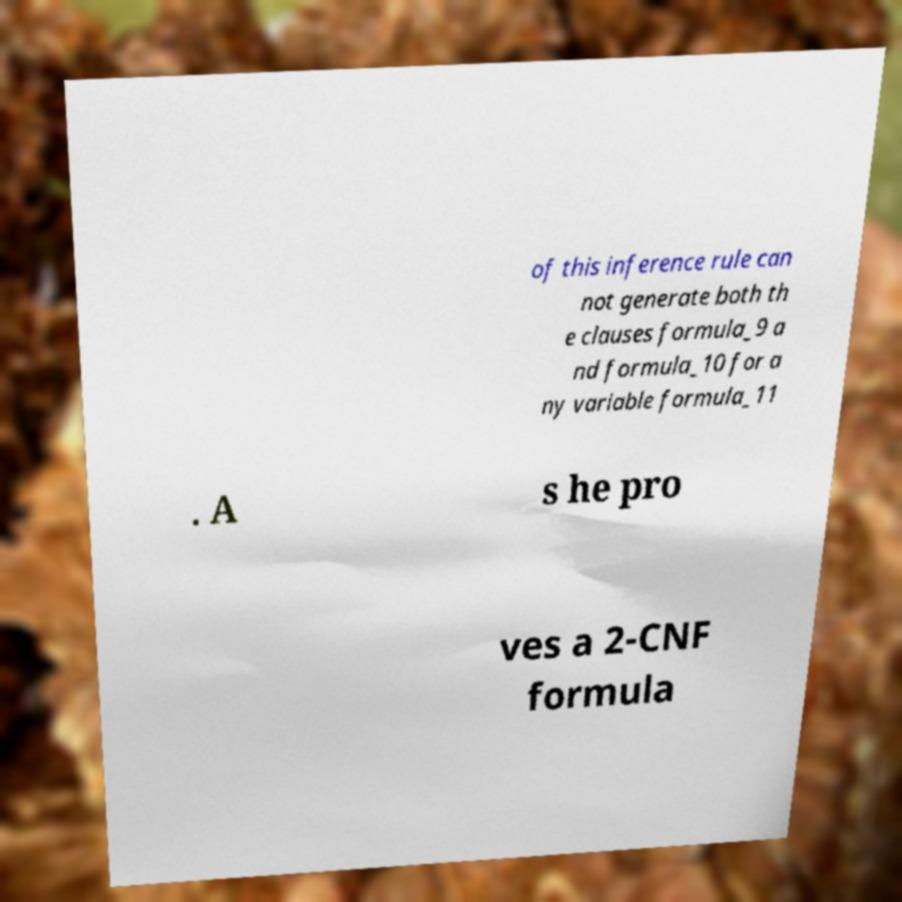There's text embedded in this image that I need extracted. Can you transcribe it verbatim? of this inference rule can not generate both th e clauses formula_9 a nd formula_10 for a ny variable formula_11 . A s he pro ves a 2-CNF formula 